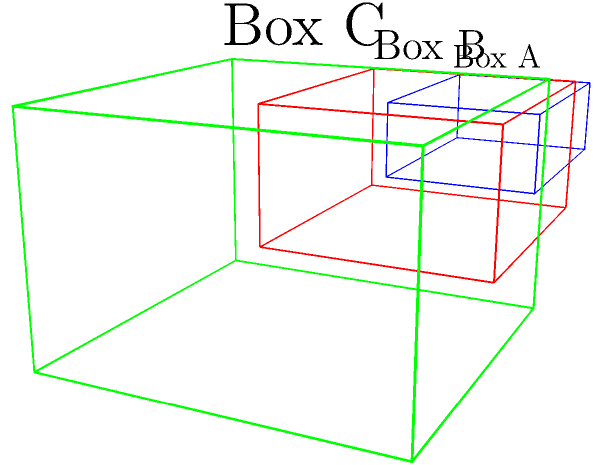As a luxury shoe enthusiast, you're organizing your collection. You have three different shoe box sizes: Box A (3x2x1), Box B (3x2.5x1.5), and Box C (3x3x2), all measured in feet. If you want to maximize storage space while ensuring your shoes are well-protected, which box should you choose for most of your collection? To determine the best storage solution, we need to compare the volumes of the shoe boxes while considering protection:

1. Calculate the volume of each box:
   Box A: $V_A = 3 \times 2 \times 1 = 6$ cubic feet
   Box B: $V_B = 3 \times 2.5 \times 1.5 = 11.25$ cubic feet
   Box C: $V_C = 3 \times 3 \times 2 = 18$ cubic feet

2. Consider space efficiency:
   Box C has the largest volume, allowing for more storage space.

3. Evaluate protection:
   Box C also has the largest dimensions, providing more cushioning and protection for luxury shoes.

4. Balance space and protection:
   While Box C offers the most space and protection, it might be excessive for smaller shoes.
   Box B provides a good balance between space efficiency and protection.

5. Consider versatility:
   Box B's medium size makes it suitable for various shoe types and sizes in a luxury collection.

Given these factors, Box B (3x2.5x1.5) offers the best balance of storage space and protection for most shoes in a luxury collection.
Answer: Box B (3x2.5x1.5) 